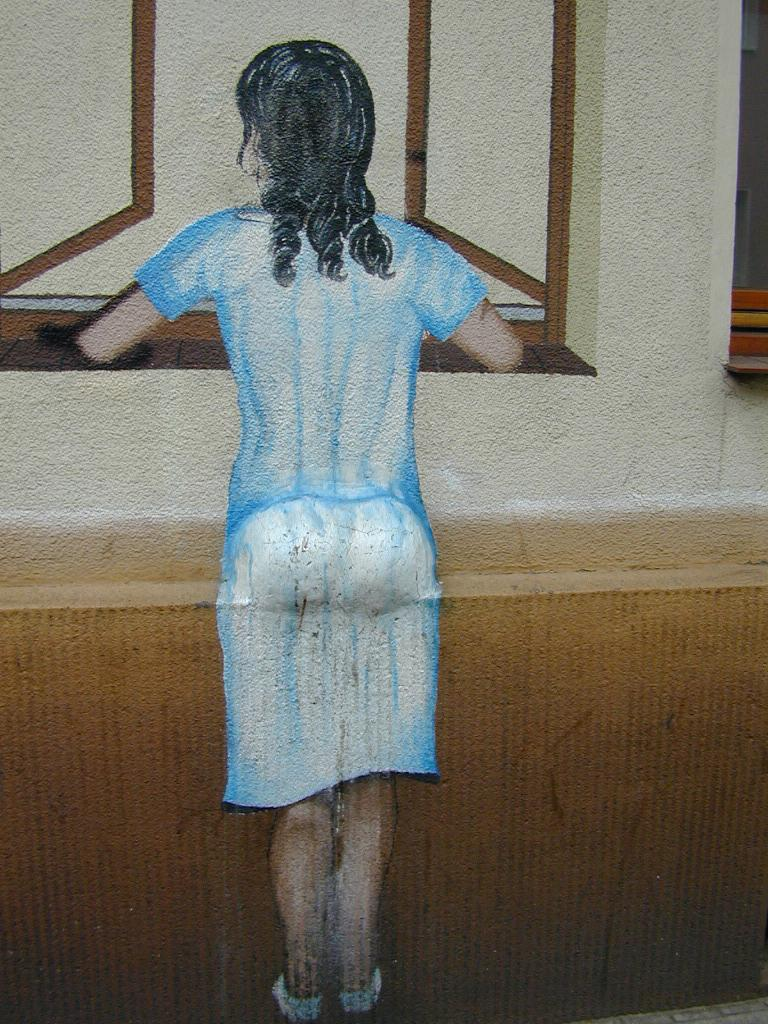What is the main subject of the painting in the image? The main subject of the painting in the image is a girl. Where is the painting located in the image? The painting is in the center of the image. What other element can be seen in the image besides the painting? There is a window in the image. What type of liquid is being poured out of the flag in the image? There is no flag or liquid present in the image; it only features a painting of a girl and a window. 